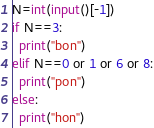Convert code to text. <code><loc_0><loc_0><loc_500><loc_500><_Python_>N=int(input()[-1])
if N==3:
  print("bon")
elif N==0 or 1 or 6 or 8:
  print("pon")
else:
  print("hon")</code> 